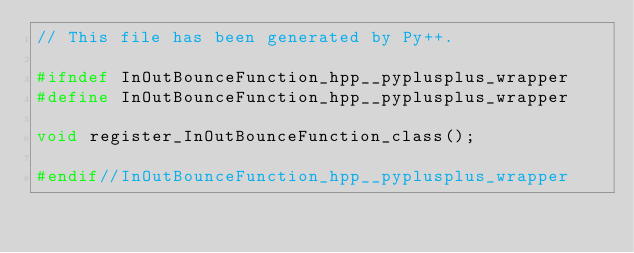Convert code to text. <code><loc_0><loc_0><loc_500><loc_500><_C++_>// This file has been generated by Py++.

#ifndef InOutBounceFunction_hpp__pyplusplus_wrapper
#define InOutBounceFunction_hpp__pyplusplus_wrapper

void register_InOutBounceFunction_class();

#endif//InOutBounceFunction_hpp__pyplusplus_wrapper
</code> 